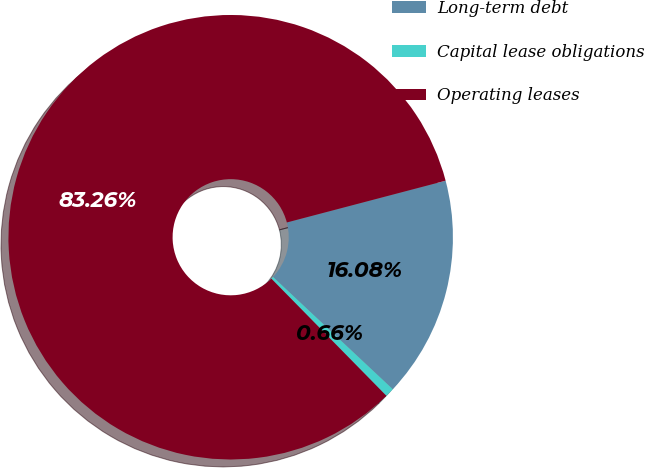<chart> <loc_0><loc_0><loc_500><loc_500><pie_chart><fcel>Long-term debt<fcel>Capital lease obligations<fcel>Operating leases<nl><fcel>16.08%<fcel>0.66%<fcel>83.26%<nl></chart> 